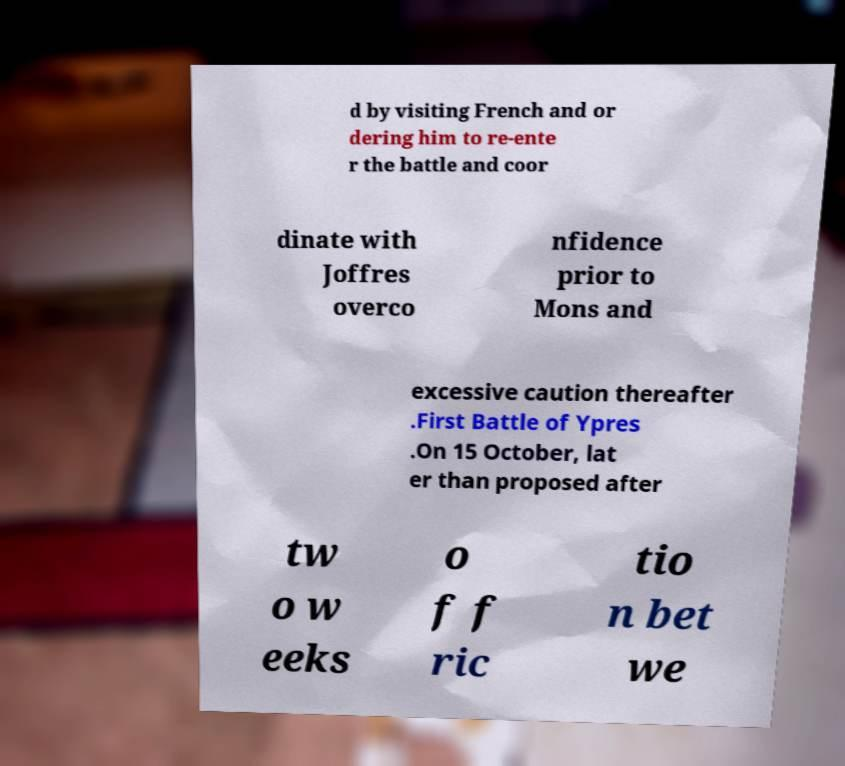What messages or text are displayed in this image? I need them in a readable, typed format. d by visiting French and or dering him to re-ente r the battle and coor dinate with Joffres overco nfidence prior to Mons and excessive caution thereafter .First Battle of Ypres .On 15 October, lat er than proposed after tw o w eeks o f f ric tio n bet we 